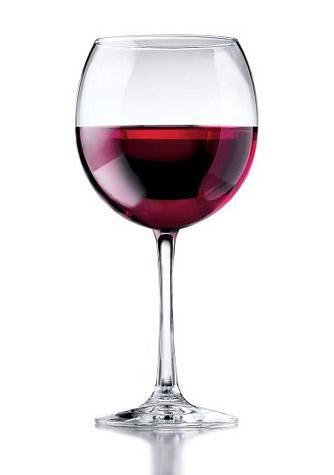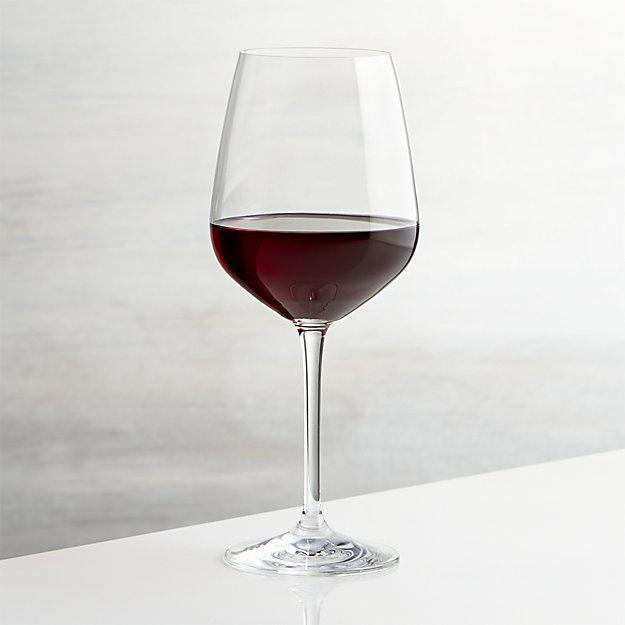The first image is the image on the left, the second image is the image on the right. Evaluate the accuracy of this statement regarding the images: "The reflection of the wineglass can be seen in the surface upon which it is sitting in the image on the left.". Is it true? Answer yes or no. Yes. 